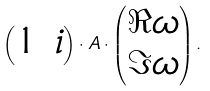Convert formula to latex. <formula><loc_0><loc_0><loc_500><loc_500>\begin{pmatrix} 1 & i \end{pmatrix} \cdot A \cdot \begin{pmatrix} \Re \omega \\ \Im \omega \end{pmatrix} .</formula> 